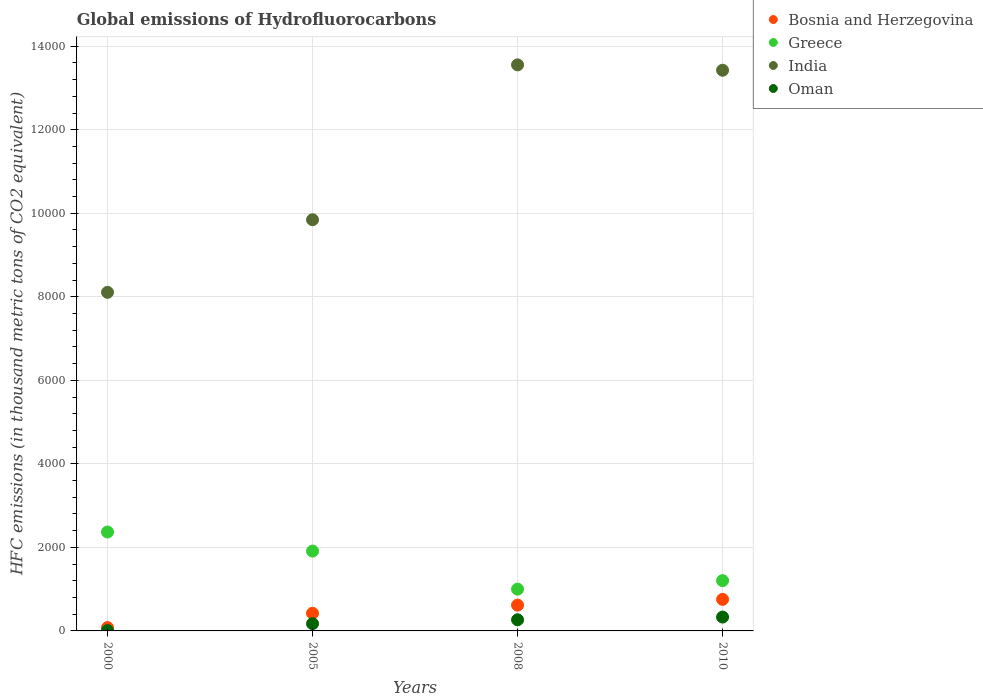What is the global emissions of Hydrofluorocarbons in Bosnia and Herzegovina in 2000?
Keep it short and to the point. 79.8. Across all years, what is the maximum global emissions of Hydrofluorocarbons in India?
Offer a very short reply. 1.36e+04. Across all years, what is the minimum global emissions of Hydrofluorocarbons in Bosnia and Herzegovina?
Your response must be concise. 79.8. In which year was the global emissions of Hydrofluorocarbons in India minimum?
Provide a short and direct response. 2000. What is the total global emissions of Hydrofluorocarbons in Oman in the graph?
Ensure brevity in your answer.  781.1. What is the difference between the global emissions of Hydrofluorocarbons in Greece in 2000 and that in 2010?
Provide a short and direct response. 1164.4. What is the difference between the global emissions of Hydrofluorocarbons in Bosnia and Herzegovina in 2005 and the global emissions of Hydrofluorocarbons in Oman in 2010?
Your response must be concise. 90.5. What is the average global emissions of Hydrofluorocarbons in Oman per year?
Ensure brevity in your answer.  195.27. In the year 2000, what is the difference between the global emissions of Hydrofluorocarbons in Oman and global emissions of Hydrofluorocarbons in Greece?
Provide a succinct answer. -2359.8. What is the ratio of the global emissions of Hydrofluorocarbons in India in 2005 to that in 2010?
Your answer should be very brief. 0.73. What is the difference between the highest and the second highest global emissions of Hydrofluorocarbons in Greece?
Give a very brief answer. 457. What is the difference between the highest and the lowest global emissions of Hydrofluorocarbons in Bosnia and Herzegovina?
Provide a short and direct response. 675.2. In how many years, is the global emissions of Hydrofluorocarbons in Oman greater than the average global emissions of Hydrofluorocarbons in Oman taken over all years?
Your answer should be compact. 2. Is the sum of the global emissions of Hydrofluorocarbons in Bosnia and Herzegovina in 2008 and 2010 greater than the maximum global emissions of Hydrofluorocarbons in Greece across all years?
Keep it short and to the point. No. Is it the case that in every year, the sum of the global emissions of Hydrofluorocarbons in Greece and global emissions of Hydrofluorocarbons in Bosnia and Herzegovina  is greater than the global emissions of Hydrofluorocarbons in Oman?
Offer a terse response. Yes. Is the global emissions of Hydrofluorocarbons in India strictly greater than the global emissions of Hydrofluorocarbons in Greece over the years?
Your response must be concise. Yes. Is the global emissions of Hydrofluorocarbons in Greece strictly less than the global emissions of Hydrofluorocarbons in India over the years?
Give a very brief answer. Yes. How many dotlines are there?
Provide a short and direct response. 4. What is the difference between two consecutive major ticks on the Y-axis?
Make the answer very short. 2000. Are the values on the major ticks of Y-axis written in scientific E-notation?
Offer a terse response. No. Does the graph contain any zero values?
Make the answer very short. No. How are the legend labels stacked?
Offer a very short reply. Vertical. What is the title of the graph?
Ensure brevity in your answer.  Global emissions of Hydrofluorocarbons. What is the label or title of the X-axis?
Give a very brief answer. Years. What is the label or title of the Y-axis?
Provide a succinct answer. HFC emissions (in thousand metric tons of CO2 equivalent). What is the HFC emissions (in thousand metric tons of CO2 equivalent) of Bosnia and Herzegovina in 2000?
Offer a terse response. 79.8. What is the HFC emissions (in thousand metric tons of CO2 equivalent) of Greece in 2000?
Offer a very short reply. 2368.4. What is the HFC emissions (in thousand metric tons of CO2 equivalent) in India in 2000?
Your response must be concise. 8107.2. What is the HFC emissions (in thousand metric tons of CO2 equivalent) of Bosnia and Herzegovina in 2005?
Make the answer very short. 422.5. What is the HFC emissions (in thousand metric tons of CO2 equivalent) in Greece in 2005?
Give a very brief answer. 1911.4. What is the HFC emissions (in thousand metric tons of CO2 equivalent) of India in 2005?
Your answer should be very brief. 9845.2. What is the HFC emissions (in thousand metric tons of CO2 equivalent) of Oman in 2005?
Your response must be concise. 173.6. What is the HFC emissions (in thousand metric tons of CO2 equivalent) in Bosnia and Herzegovina in 2008?
Your answer should be very brief. 617.6. What is the HFC emissions (in thousand metric tons of CO2 equivalent) in Greece in 2008?
Make the answer very short. 1000.3. What is the HFC emissions (in thousand metric tons of CO2 equivalent) of India in 2008?
Offer a very short reply. 1.36e+04. What is the HFC emissions (in thousand metric tons of CO2 equivalent) in Oman in 2008?
Provide a succinct answer. 266.9. What is the HFC emissions (in thousand metric tons of CO2 equivalent) in Bosnia and Herzegovina in 2010?
Provide a short and direct response. 755. What is the HFC emissions (in thousand metric tons of CO2 equivalent) in Greece in 2010?
Make the answer very short. 1204. What is the HFC emissions (in thousand metric tons of CO2 equivalent) in India in 2010?
Your answer should be compact. 1.34e+04. What is the HFC emissions (in thousand metric tons of CO2 equivalent) of Oman in 2010?
Your answer should be very brief. 332. Across all years, what is the maximum HFC emissions (in thousand metric tons of CO2 equivalent) in Bosnia and Herzegovina?
Ensure brevity in your answer.  755. Across all years, what is the maximum HFC emissions (in thousand metric tons of CO2 equivalent) in Greece?
Make the answer very short. 2368.4. Across all years, what is the maximum HFC emissions (in thousand metric tons of CO2 equivalent) of India?
Your answer should be compact. 1.36e+04. Across all years, what is the maximum HFC emissions (in thousand metric tons of CO2 equivalent) in Oman?
Your response must be concise. 332. Across all years, what is the minimum HFC emissions (in thousand metric tons of CO2 equivalent) in Bosnia and Herzegovina?
Provide a succinct answer. 79.8. Across all years, what is the minimum HFC emissions (in thousand metric tons of CO2 equivalent) of Greece?
Your response must be concise. 1000.3. Across all years, what is the minimum HFC emissions (in thousand metric tons of CO2 equivalent) of India?
Your response must be concise. 8107.2. What is the total HFC emissions (in thousand metric tons of CO2 equivalent) of Bosnia and Herzegovina in the graph?
Your response must be concise. 1874.9. What is the total HFC emissions (in thousand metric tons of CO2 equivalent) in Greece in the graph?
Offer a very short reply. 6484.1. What is the total HFC emissions (in thousand metric tons of CO2 equivalent) of India in the graph?
Your answer should be very brief. 4.49e+04. What is the total HFC emissions (in thousand metric tons of CO2 equivalent) in Oman in the graph?
Offer a terse response. 781.1. What is the difference between the HFC emissions (in thousand metric tons of CO2 equivalent) in Bosnia and Herzegovina in 2000 and that in 2005?
Keep it short and to the point. -342.7. What is the difference between the HFC emissions (in thousand metric tons of CO2 equivalent) of Greece in 2000 and that in 2005?
Make the answer very short. 457. What is the difference between the HFC emissions (in thousand metric tons of CO2 equivalent) of India in 2000 and that in 2005?
Your answer should be compact. -1738. What is the difference between the HFC emissions (in thousand metric tons of CO2 equivalent) in Oman in 2000 and that in 2005?
Keep it short and to the point. -165. What is the difference between the HFC emissions (in thousand metric tons of CO2 equivalent) in Bosnia and Herzegovina in 2000 and that in 2008?
Give a very brief answer. -537.8. What is the difference between the HFC emissions (in thousand metric tons of CO2 equivalent) of Greece in 2000 and that in 2008?
Give a very brief answer. 1368.1. What is the difference between the HFC emissions (in thousand metric tons of CO2 equivalent) of India in 2000 and that in 2008?
Offer a terse response. -5446.5. What is the difference between the HFC emissions (in thousand metric tons of CO2 equivalent) of Oman in 2000 and that in 2008?
Your response must be concise. -258.3. What is the difference between the HFC emissions (in thousand metric tons of CO2 equivalent) in Bosnia and Herzegovina in 2000 and that in 2010?
Provide a short and direct response. -675.2. What is the difference between the HFC emissions (in thousand metric tons of CO2 equivalent) of Greece in 2000 and that in 2010?
Give a very brief answer. 1164.4. What is the difference between the HFC emissions (in thousand metric tons of CO2 equivalent) in India in 2000 and that in 2010?
Your answer should be very brief. -5317.8. What is the difference between the HFC emissions (in thousand metric tons of CO2 equivalent) of Oman in 2000 and that in 2010?
Give a very brief answer. -323.4. What is the difference between the HFC emissions (in thousand metric tons of CO2 equivalent) in Bosnia and Herzegovina in 2005 and that in 2008?
Make the answer very short. -195.1. What is the difference between the HFC emissions (in thousand metric tons of CO2 equivalent) in Greece in 2005 and that in 2008?
Your answer should be compact. 911.1. What is the difference between the HFC emissions (in thousand metric tons of CO2 equivalent) of India in 2005 and that in 2008?
Your answer should be compact. -3708.5. What is the difference between the HFC emissions (in thousand metric tons of CO2 equivalent) of Oman in 2005 and that in 2008?
Offer a very short reply. -93.3. What is the difference between the HFC emissions (in thousand metric tons of CO2 equivalent) in Bosnia and Herzegovina in 2005 and that in 2010?
Offer a terse response. -332.5. What is the difference between the HFC emissions (in thousand metric tons of CO2 equivalent) in Greece in 2005 and that in 2010?
Keep it short and to the point. 707.4. What is the difference between the HFC emissions (in thousand metric tons of CO2 equivalent) of India in 2005 and that in 2010?
Offer a very short reply. -3579.8. What is the difference between the HFC emissions (in thousand metric tons of CO2 equivalent) in Oman in 2005 and that in 2010?
Your answer should be very brief. -158.4. What is the difference between the HFC emissions (in thousand metric tons of CO2 equivalent) in Bosnia and Herzegovina in 2008 and that in 2010?
Your answer should be compact. -137.4. What is the difference between the HFC emissions (in thousand metric tons of CO2 equivalent) of Greece in 2008 and that in 2010?
Provide a succinct answer. -203.7. What is the difference between the HFC emissions (in thousand metric tons of CO2 equivalent) of India in 2008 and that in 2010?
Provide a short and direct response. 128.7. What is the difference between the HFC emissions (in thousand metric tons of CO2 equivalent) in Oman in 2008 and that in 2010?
Ensure brevity in your answer.  -65.1. What is the difference between the HFC emissions (in thousand metric tons of CO2 equivalent) of Bosnia and Herzegovina in 2000 and the HFC emissions (in thousand metric tons of CO2 equivalent) of Greece in 2005?
Keep it short and to the point. -1831.6. What is the difference between the HFC emissions (in thousand metric tons of CO2 equivalent) of Bosnia and Herzegovina in 2000 and the HFC emissions (in thousand metric tons of CO2 equivalent) of India in 2005?
Give a very brief answer. -9765.4. What is the difference between the HFC emissions (in thousand metric tons of CO2 equivalent) of Bosnia and Herzegovina in 2000 and the HFC emissions (in thousand metric tons of CO2 equivalent) of Oman in 2005?
Provide a succinct answer. -93.8. What is the difference between the HFC emissions (in thousand metric tons of CO2 equivalent) of Greece in 2000 and the HFC emissions (in thousand metric tons of CO2 equivalent) of India in 2005?
Ensure brevity in your answer.  -7476.8. What is the difference between the HFC emissions (in thousand metric tons of CO2 equivalent) in Greece in 2000 and the HFC emissions (in thousand metric tons of CO2 equivalent) in Oman in 2005?
Offer a very short reply. 2194.8. What is the difference between the HFC emissions (in thousand metric tons of CO2 equivalent) of India in 2000 and the HFC emissions (in thousand metric tons of CO2 equivalent) of Oman in 2005?
Your answer should be compact. 7933.6. What is the difference between the HFC emissions (in thousand metric tons of CO2 equivalent) of Bosnia and Herzegovina in 2000 and the HFC emissions (in thousand metric tons of CO2 equivalent) of Greece in 2008?
Make the answer very short. -920.5. What is the difference between the HFC emissions (in thousand metric tons of CO2 equivalent) in Bosnia and Herzegovina in 2000 and the HFC emissions (in thousand metric tons of CO2 equivalent) in India in 2008?
Your response must be concise. -1.35e+04. What is the difference between the HFC emissions (in thousand metric tons of CO2 equivalent) of Bosnia and Herzegovina in 2000 and the HFC emissions (in thousand metric tons of CO2 equivalent) of Oman in 2008?
Provide a short and direct response. -187.1. What is the difference between the HFC emissions (in thousand metric tons of CO2 equivalent) of Greece in 2000 and the HFC emissions (in thousand metric tons of CO2 equivalent) of India in 2008?
Provide a succinct answer. -1.12e+04. What is the difference between the HFC emissions (in thousand metric tons of CO2 equivalent) of Greece in 2000 and the HFC emissions (in thousand metric tons of CO2 equivalent) of Oman in 2008?
Your answer should be compact. 2101.5. What is the difference between the HFC emissions (in thousand metric tons of CO2 equivalent) of India in 2000 and the HFC emissions (in thousand metric tons of CO2 equivalent) of Oman in 2008?
Provide a succinct answer. 7840.3. What is the difference between the HFC emissions (in thousand metric tons of CO2 equivalent) of Bosnia and Herzegovina in 2000 and the HFC emissions (in thousand metric tons of CO2 equivalent) of Greece in 2010?
Your answer should be very brief. -1124.2. What is the difference between the HFC emissions (in thousand metric tons of CO2 equivalent) of Bosnia and Herzegovina in 2000 and the HFC emissions (in thousand metric tons of CO2 equivalent) of India in 2010?
Offer a very short reply. -1.33e+04. What is the difference between the HFC emissions (in thousand metric tons of CO2 equivalent) of Bosnia and Herzegovina in 2000 and the HFC emissions (in thousand metric tons of CO2 equivalent) of Oman in 2010?
Offer a very short reply. -252.2. What is the difference between the HFC emissions (in thousand metric tons of CO2 equivalent) in Greece in 2000 and the HFC emissions (in thousand metric tons of CO2 equivalent) in India in 2010?
Offer a very short reply. -1.11e+04. What is the difference between the HFC emissions (in thousand metric tons of CO2 equivalent) of Greece in 2000 and the HFC emissions (in thousand metric tons of CO2 equivalent) of Oman in 2010?
Give a very brief answer. 2036.4. What is the difference between the HFC emissions (in thousand metric tons of CO2 equivalent) of India in 2000 and the HFC emissions (in thousand metric tons of CO2 equivalent) of Oman in 2010?
Your response must be concise. 7775.2. What is the difference between the HFC emissions (in thousand metric tons of CO2 equivalent) of Bosnia and Herzegovina in 2005 and the HFC emissions (in thousand metric tons of CO2 equivalent) of Greece in 2008?
Your answer should be compact. -577.8. What is the difference between the HFC emissions (in thousand metric tons of CO2 equivalent) in Bosnia and Herzegovina in 2005 and the HFC emissions (in thousand metric tons of CO2 equivalent) in India in 2008?
Keep it short and to the point. -1.31e+04. What is the difference between the HFC emissions (in thousand metric tons of CO2 equivalent) in Bosnia and Herzegovina in 2005 and the HFC emissions (in thousand metric tons of CO2 equivalent) in Oman in 2008?
Give a very brief answer. 155.6. What is the difference between the HFC emissions (in thousand metric tons of CO2 equivalent) of Greece in 2005 and the HFC emissions (in thousand metric tons of CO2 equivalent) of India in 2008?
Your response must be concise. -1.16e+04. What is the difference between the HFC emissions (in thousand metric tons of CO2 equivalent) in Greece in 2005 and the HFC emissions (in thousand metric tons of CO2 equivalent) in Oman in 2008?
Your answer should be very brief. 1644.5. What is the difference between the HFC emissions (in thousand metric tons of CO2 equivalent) of India in 2005 and the HFC emissions (in thousand metric tons of CO2 equivalent) of Oman in 2008?
Your answer should be very brief. 9578.3. What is the difference between the HFC emissions (in thousand metric tons of CO2 equivalent) in Bosnia and Herzegovina in 2005 and the HFC emissions (in thousand metric tons of CO2 equivalent) in Greece in 2010?
Your response must be concise. -781.5. What is the difference between the HFC emissions (in thousand metric tons of CO2 equivalent) in Bosnia and Herzegovina in 2005 and the HFC emissions (in thousand metric tons of CO2 equivalent) in India in 2010?
Offer a very short reply. -1.30e+04. What is the difference between the HFC emissions (in thousand metric tons of CO2 equivalent) in Bosnia and Herzegovina in 2005 and the HFC emissions (in thousand metric tons of CO2 equivalent) in Oman in 2010?
Keep it short and to the point. 90.5. What is the difference between the HFC emissions (in thousand metric tons of CO2 equivalent) of Greece in 2005 and the HFC emissions (in thousand metric tons of CO2 equivalent) of India in 2010?
Offer a terse response. -1.15e+04. What is the difference between the HFC emissions (in thousand metric tons of CO2 equivalent) in Greece in 2005 and the HFC emissions (in thousand metric tons of CO2 equivalent) in Oman in 2010?
Your response must be concise. 1579.4. What is the difference between the HFC emissions (in thousand metric tons of CO2 equivalent) of India in 2005 and the HFC emissions (in thousand metric tons of CO2 equivalent) of Oman in 2010?
Provide a short and direct response. 9513.2. What is the difference between the HFC emissions (in thousand metric tons of CO2 equivalent) of Bosnia and Herzegovina in 2008 and the HFC emissions (in thousand metric tons of CO2 equivalent) of Greece in 2010?
Make the answer very short. -586.4. What is the difference between the HFC emissions (in thousand metric tons of CO2 equivalent) in Bosnia and Herzegovina in 2008 and the HFC emissions (in thousand metric tons of CO2 equivalent) in India in 2010?
Offer a very short reply. -1.28e+04. What is the difference between the HFC emissions (in thousand metric tons of CO2 equivalent) in Bosnia and Herzegovina in 2008 and the HFC emissions (in thousand metric tons of CO2 equivalent) in Oman in 2010?
Offer a terse response. 285.6. What is the difference between the HFC emissions (in thousand metric tons of CO2 equivalent) in Greece in 2008 and the HFC emissions (in thousand metric tons of CO2 equivalent) in India in 2010?
Your response must be concise. -1.24e+04. What is the difference between the HFC emissions (in thousand metric tons of CO2 equivalent) in Greece in 2008 and the HFC emissions (in thousand metric tons of CO2 equivalent) in Oman in 2010?
Offer a very short reply. 668.3. What is the difference between the HFC emissions (in thousand metric tons of CO2 equivalent) in India in 2008 and the HFC emissions (in thousand metric tons of CO2 equivalent) in Oman in 2010?
Your answer should be very brief. 1.32e+04. What is the average HFC emissions (in thousand metric tons of CO2 equivalent) in Bosnia and Herzegovina per year?
Your answer should be very brief. 468.73. What is the average HFC emissions (in thousand metric tons of CO2 equivalent) in Greece per year?
Keep it short and to the point. 1621.03. What is the average HFC emissions (in thousand metric tons of CO2 equivalent) in India per year?
Your response must be concise. 1.12e+04. What is the average HFC emissions (in thousand metric tons of CO2 equivalent) of Oman per year?
Provide a succinct answer. 195.28. In the year 2000, what is the difference between the HFC emissions (in thousand metric tons of CO2 equivalent) of Bosnia and Herzegovina and HFC emissions (in thousand metric tons of CO2 equivalent) of Greece?
Provide a short and direct response. -2288.6. In the year 2000, what is the difference between the HFC emissions (in thousand metric tons of CO2 equivalent) of Bosnia and Herzegovina and HFC emissions (in thousand metric tons of CO2 equivalent) of India?
Your answer should be compact. -8027.4. In the year 2000, what is the difference between the HFC emissions (in thousand metric tons of CO2 equivalent) of Bosnia and Herzegovina and HFC emissions (in thousand metric tons of CO2 equivalent) of Oman?
Offer a very short reply. 71.2. In the year 2000, what is the difference between the HFC emissions (in thousand metric tons of CO2 equivalent) of Greece and HFC emissions (in thousand metric tons of CO2 equivalent) of India?
Offer a very short reply. -5738.8. In the year 2000, what is the difference between the HFC emissions (in thousand metric tons of CO2 equivalent) in Greece and HFC emissions (in thousand metric tons of CO2 equivalent) in Oman?
Make the answer very short. 2359.8. In the year 2000, what is the difference between the HFC emissions (in thousand metric tons of CO2 equivalent) of India and HFC emissions (in thousand metric tons of CO2 equivalent) of Oman?
Provide a succinct answer. 8098.6. In the year 2005, what is the difference between the HFC emissions (in thousand metric tons of CO2 equivalent) in Bosnia and Herzegovina and HFC emissions (in thousand metric tons of CO2 equivalent) in Greece?
Keep it short and to the point. -1488.9. In the year 2005, what is the difference between the HFC emissions (in thousand metric tons of CO2 equivalent) of Bosnia and Herzegovina and HFC emissions (in thousand metric tons of CO2 equivalent) of India?
Offer a terse response. -9422.7. In the year 2005, what is the difference between the HFC emissions (in thousand metric tons of CO2 equivalent) in Bosnia and Herzegovina and HFC emissions (in thousand metric tons of CO2 equivalent) in Oman?
Provide a short and direct response. 248.9. In the year 2005, what is the difference between the HFC emissions (in thousand metric tons of CO2 equivalent) of Greece and HFC emissions (in thousand metric tons of CO2 equivalent) of India?
Provide a succinct answer. -7933.8. In the year 2005, what is the difference between the HFC emissions (in thousand metric tons of CO2 equivalent) of Greece and HFC emissions (in thousand metric tons of CO2 equivalent) of Oman?
Give a very brief answer. 1737.8. In the year 2005, what is the difference between the HFC emissions (in thousand metric tons of CO2 equivalent) of India and HFC emissions (in thousand metric tons of CO2 equivalent) of Oman?
Offer a terse response. 9671.6. In the year 2008, what is the difference between the HFC emissions (in thousand metric tons of CO2 equivalent) in Bosnia and Herzegovina and HFC emissions (in thousand metric tons of CO2 equivalent) in Greece?
Provide a short and direct response. -382.7. In the year 2008, what is the difference between the HFC emissions (in thousand metric tons of CO2 equivalent) of Bosnia and Herzegovina and HFC emissions (in thousand metric tons of CO2 equivalent) of India?
Give a very brief answer. -1.29e+04. In the year 2008, what is the difference between the HFC emissions (in thousand metric tons of CO2 equivalent) of Bosnia and Herzegovina and HFC emissions (in thousand metric tons of CO2 equivalent) of Oman?
Offer a very short reply. 350.7. In the year 2008, what is the difference between the HFC emissions (in thousand metric tons of CO2 equivalent) of Greece and HFC emissions (in thousand metric tons of CO2 equivalent) of India?
Ensure brevity in your answer.  -1.26e+04. In the year 2008, what is the difference between the HFC emissions (in thousand metric tons of CO2 equivalent) of Greece and HFC emissions (in thousand metric tons of CO2 equivalent) of Oman?
Your answer should be compact. 733.4. In the year 2008, what is the difference between the HFC emissions (in thousand metric tons of CO2 equivalent) of India and HFC emissions (in thousand metric tons of CO2 equivalent) of Oman?
Your response must be concise. 1.33e+04. In the year 2010, what is the difference between the HFC emissions (in thousand metric tons of CO2 equivalent) of Bosnia and Herzegovina and HFC emissions (in thousand metric tons of CO2 equivalent) of Greece?
Provide a succinct answer. -449. In the year 2010, what is the difference between the HFC emissions (in thousand metric tons of CO2 equivalent) of Bosnia and Herzegovina and HFC emissions (in thousand metric tons of CO2 equivalent) of India?
Your answer should be compact. -1.27e+04. In the year 2010, what is the difference between the HFC emissions (in thousand metric tons of CO2 equivalent) of Bosnia and Herzegovina and HFC emissions (in thousand metric tons of CO2 equivalent) of Oman?
Your response must be concise. 423. In the year 2010, what is the difference between the HFC emissions (in thousand metric tons of CO2 equivalent) of Greece and HFC emissions (in thousand metric tons of CO2 equivalent) of India?
Provide a short and direct response. -1.22e+04. In the year 2010, what is the difference between the HFC emissions (in thousand metric tons of CO2 equivalent) in Greece and HFC emissions (in thousand metric tons of CO2 equivalent) in Oman?
Your answer should be compact. 872. In the year 2010, what is the difference between the HFC emissions (in thousand metric tons of CO2 equivalent) in India and HFC emissions (in thousand metric tons of CO2 equivalent) in Oman?
Give a very brief answer. 1.31e+04. What is the ratio of the HFC emissions (in thousand metric tons of CO2 equivalent) in Bosnia and Herzegovina in 2000 to that in 2005?
Provide a succinct answer. 0.19. What is the ratio of the HFC emissions (in thousand metric tons of CO2 equivalent) of Greece in 2000 to that in 2005?
Make the answer very short. 1.24. What is the ratio of the HFC emissions (in thousand metric tons of CO2 equivalent) of India in 2000 to that in 2005?
Provide a short and direct response. 0.82. What is the ratio of the HFC emissions (in thousand metric tons of CO2 equivalent) in Oman in 2000 to that in 2005?
Give a very brief answer. 0.05. What is the ratio of the HFC emissions (in thousand metric tons of CO2 equivalent) of Bosnia and Herzegovina in 2000 to that in 2008?
Your answer should be very brief. 0.13. What is the ratio of the HFC emissions (in thousand metric tons of CO2 equivalent) in Greece in 2000 to that in 2008?
Your response must be concise. 2.37. What is the ratio of the HFC emissions (in thousand metric tons of CO2 equivalent) of India in 2000 to that in 2008?
Your answer should be very brief. 0.6. What is the ratio of the HFC emissions (in thousand metric tons of CO2 equivalent) in Oman in 2000 to that in 2008?
Your response must be concise. 0.03. What is the ratio of the HFC emissions (in thousand metric tons of CO2 equivalent) in Bosnia and Herzegovina in 2000 to that in 2010?
Provide a succinct answer. 0.11. What is the ratio of the HFC emissions (in thousand metric tons of CO2 equivalent) in Greece in 2000 to that in 2010?
Give a very brief answer. 1.97. What is the ratio of the HFC emissions (in thousand metric tons of CO2 equivalent) in India in 2000 to that in 2010?
Keep it short and to the point. 0.6. What is the ratio of the HFC emissions (in thousand metric tons of CO2 equivalent) of Oman in 2000 to that in 2010?
Your response must be concise. 0.03. What is the ratio of the HFC emissions (in thousand metric tons of CO2 equivalent) in Bosnia and Herzegovina in 2005 to that in 2008?
Offer a terse response. 0.68. What is the ratio of the HFC emissions (in thousand metric tons of CO2 equivalent) of Greece in 2005 to that in 2008?
Your response must be concise. 1.91. What is the ratio of the HFC emissions (in thousand metric tons of CO2 equivalent) in India in 2005 to that in 2008?
Offer a very short reply. 0.73. What is the ratio of the HFC emissions (in thousand metric tons of CO2 equivalent) in Oman in 2005 to that in 2008?
Provide a short and direct response. 0.65. What is the ratio of the HFC emissions (in thousand metric tons of CO2 equivalent) in Bosnia and Herzegovina in 2005 to that in 2010?
Your answer should be compact. 0.56. What is the ratio of the HFC emissions (in thousand metric tons of CO2 equivalent) in Greece in 2005 to that in 2010?
Offer a very short reply. 1.59. What is the ratio of the HFC emissions (in thousand metric tons of CO2 equivalent) in India in 2005 to that in 2010?
Your answer should be compact. 0.73. What is the ratio of the HFC emissions (in thousand metric tons of CO2 equivalent) in Oman in 2005 to that in 2010?
Offer a very short reply. 0.52. What is the ratio of the HFC emissions (in thousand metric tons of CO2 equivalent) in Bosnia and Herzegovina in 2008 to that in 2010?
Offer a terse response. 0.82. What is the ratio of the HFC emissions (in thousand metric tons of CO2 equivalent) in Greece in 2008 to that in 2010?
Your answer should be very brief. 0.83. What is the ratio of the HFC emissions (in thousand metric tons of CO2 equivalent) in India in 2008 to that in 2010?
Offer a very short reply. 1.01. What is the ratio of the HFC emissions (in thousand metric tons of CO2 equivalent) in Oman in 2008 to that in 2010?
Offer a very short reply. 0.8. What is the difference between the highest and the second highest HFC emissions (in thousand metric tons of CO2 equivalent) in Bosnia and Herzegovina?
Offer a terse response. 137.4. What is the difference between the highest and the second highest HFC emissions (in thousand metric tons of CO2 equivalent) in Greece?
Give a very brief answer. 457. What is the difference between the highest and the second highest HFC emissions (in thousand metric tons of CO2 equivalent) of India?
Keep it short and to the point. 128.7. What is the difference between the highest and the second highest HFC emissions (in thousand metric tons of CO2 equivalent) of Oman?
Keep it short and to the point. 65.1. What is the difference between the highest and the lowest HFC emissions (in thousand metric tons of CO2 equivalent) of Bosnia and Herzegovina?
Keep it short and to the point. 675.2. What is the difference between the highest and the lowest HFC emissions (in thousand metric tons of CO2 equivalent) of Greece?
Provide a short and direct response. 1368.1. What is the difference between the highest and the lowest HFC emissions (in thousand metric tons of CO2 equivalent) in India?
Give a very brief answer. 5446.5. What is the difference between the highest and the lowest HFC emissions (in thousand metric tons of CO2 equivalent) in Oman?
Offer a terse response. 323.4. 